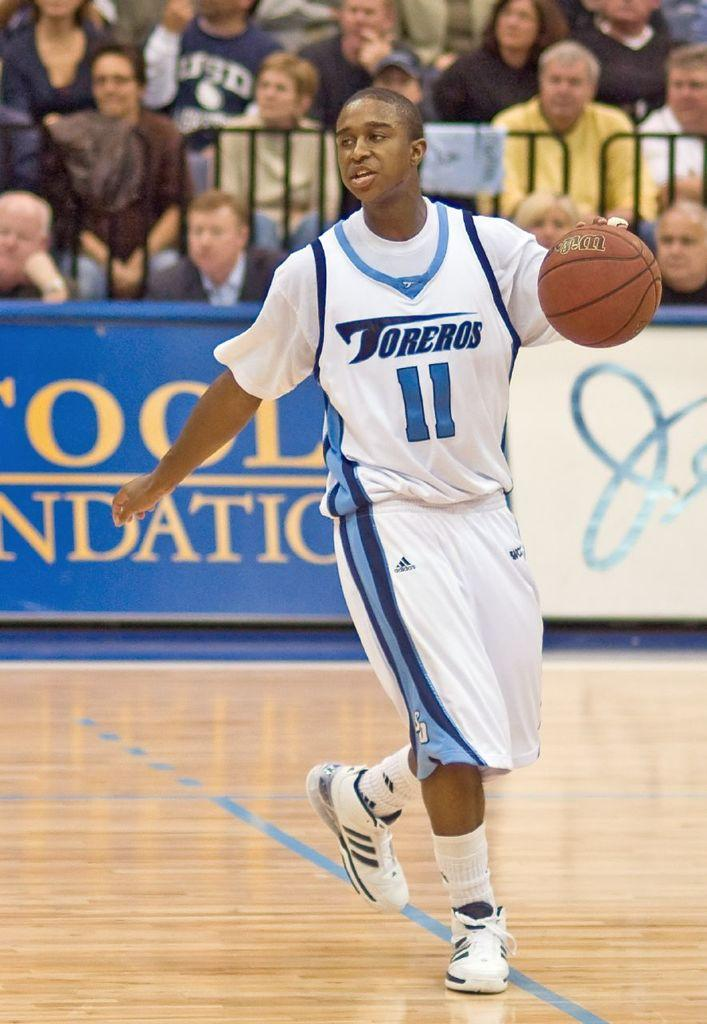<image>
Present a compact description of the photo's key features. a player that has the number 11 on their jersey 